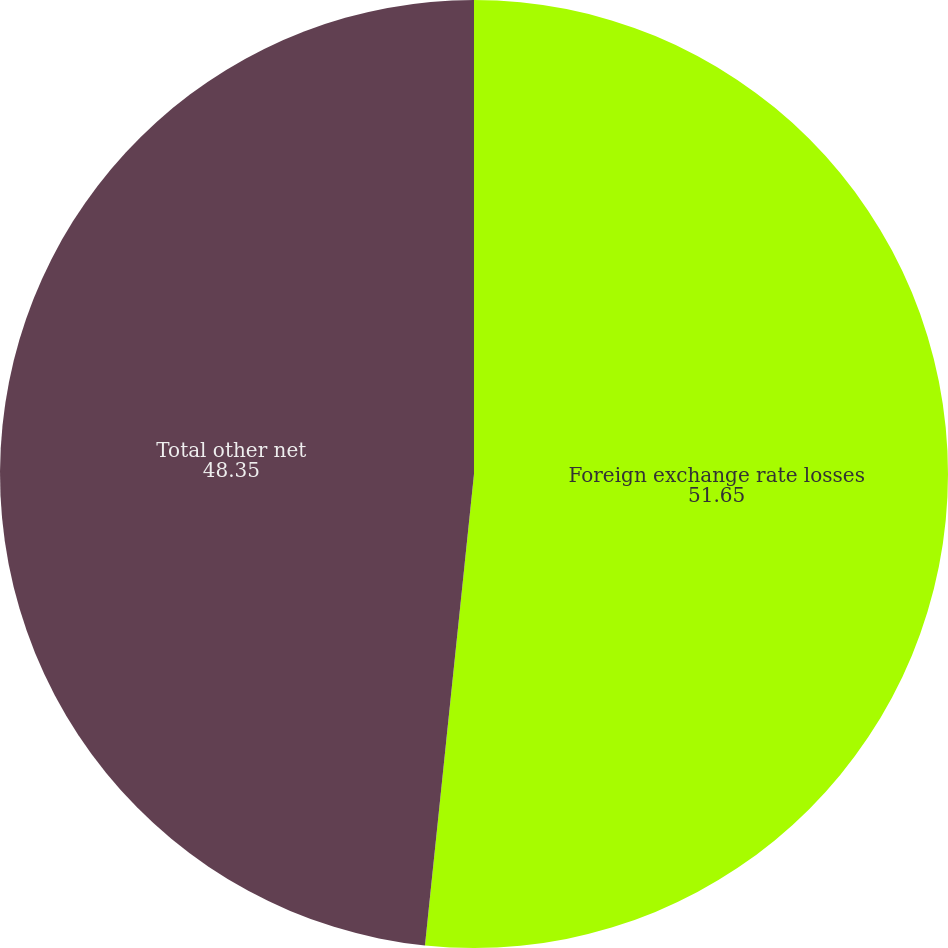Convert chart to OTSL. <chart><loc_0><loc_0><loc_500><loc_500><pie_chart><fcel>Foreign exchange rate losses<fcel>Total other net<nl><fcel>51.65%<fcel>48.35%<nl></chart> 